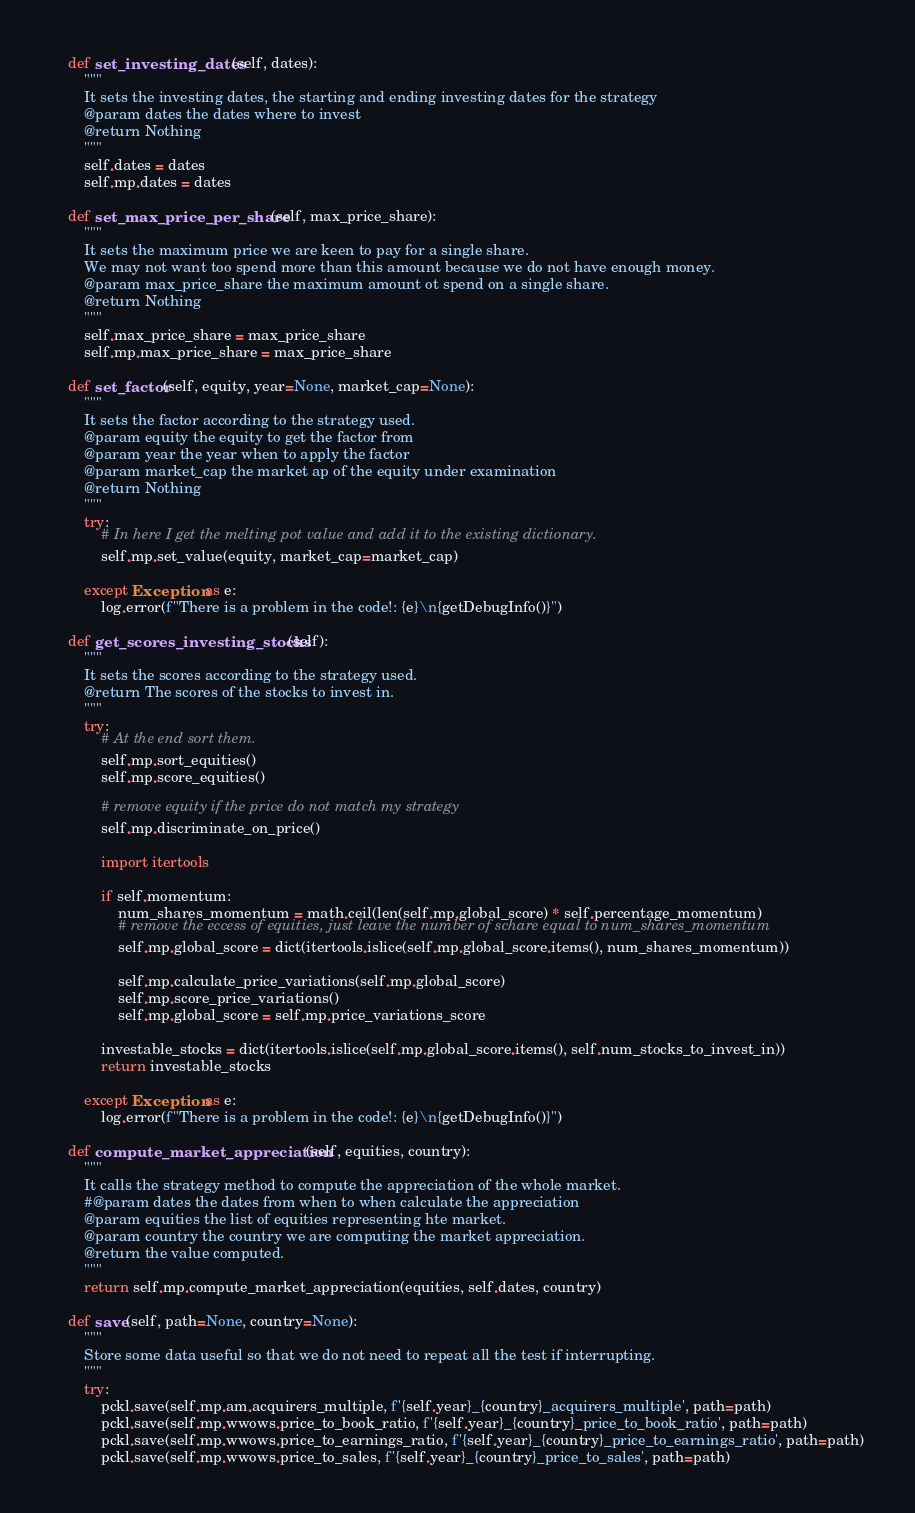<code> <loc_0><loc_0><loc_500><loc_500><_Python_>    def set_investing_dates(self, dates):
        """
        It sets the investing dates, the starting and ending investing dates for the strategy
        @param dates the dates where to invest
        @return Nothing
        """
        self.dates = dates
        self.mp.dates = dates

    def set_max_price_per_share(self, max_price_share):
        """
        It sets the maximum price we are keen to pay for a single share.
        We may not want too spend more than this amount because we do not have enough money.
        @param max_price_share the maximum amount ot spend on a single share.
        @return Nothing
        """
        self.max_price_share = max_price_share
        self.mp.max_price_share = max_price_share

    def set_factor(self, equity, year=None, market_cap=None):
        """
        It sets the factor according to the strategy used.
        @param equity the equity to get the factor from
        @param year the year when to apply the factor
        @param market_cap the market ap of the equity under examination
        @return Nothing
        """
        try:
            # In here I get the melting pot value and add it to the existing dictionary.
            self.mp.set_value(equity, market_cap=market_cap)

        except Exception as e:
            log.error(f"There is a problem in the code!: {e}\n{getDebugInfo()}")

    def get_scores_investing_stocks(self):
        """
        It sets the scores according to the strategy used.
        @return The scores of the stocks to invest in.
        """
        try:
            # At the end sort them.
            self.mp.sort_equities()
            self.mp.score_equities()

            # remove equity if the price do not match my strategy
            self.mp.discriminate_on_price()

            import itertools

            if self.momentum:
                num_shares_momentum = math.ceil(len(self.mp.global_score) * self.percentage_momentum)
                # remove the eccess of equities, just leave the number of schare equal to num_shares_momentum
                self.mp.global_score = dict(itertools.islice(self.mp.global_score.items(), num_shares_momentum))

                self.mp.calculate_price_variations(self.mp.global_score)
                self.mp.score_price_variations()
                self.mp.global_score = self.mp.price_variations_score

            investable_stocks = dict(itertools.islice(self.mp.global_score.items(), self.num_stocks_to_invest_in))
            return investable_stocks

        except Exception as e:
            log.error(f"There is a problem in the code!: {e}\n{getDebugInfo()}")

    def compute_market_appreciation(self, equities, country):
        """
        It calls the strategy method to compute the appreciation of the whole market.
        #@param dates the dates from when to when calculate the appreciation
        @param equities the list of equities representing hte market.
        @param country the country we are computing the market appreciation.
        @return the value computed.
        """
        return self.mp.compute_market_appreciation(equities, self.dates, country)

    def save(self, path=None, country=None):
        """
        Store some data useful so that we do not need to repeat all the test if interrupting.
        """
        try:
            pckl.save(self.mp.am.acquirers_multiple, f'{self.year}_{country}_acquirers_multiple', path=path)
            pckl.save(self.mp.wwows.price_to_book_ratio, f'{self.year}_{country}_price_to_book_ratio', path=path)
            pckl.save(self.mp.wwows.price_to_earnings_ratio, f'{self.year}_{country}_price_to_earnings_ratio', path=path)
            pckl.save(self.mp.wwows.price_to_sales, f'{self.year}_{country}_price_to_sales', path=path)</code> 